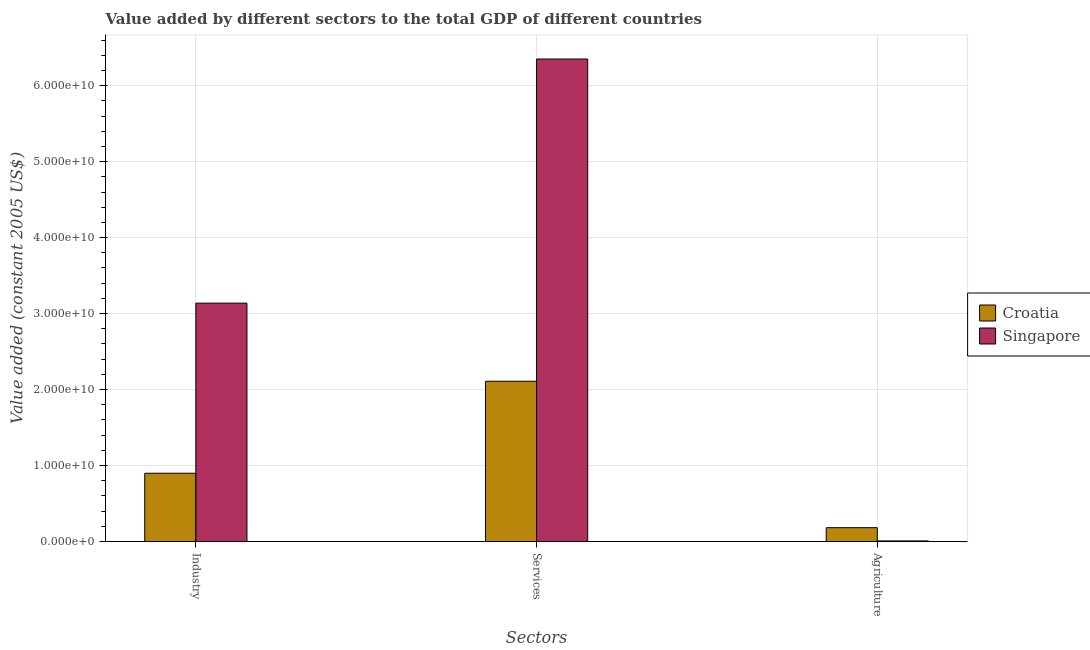Are the number of bars per tick equal to the number of legend labels?
Give a very brief answer. Yes. How many bars are there on the 3rd tick from the right?
Your answer should be very brief. 2. What is the label of the 3rd group of bars from the left?
Keep it short and to the point. Agriculture. What is the value added by industrial sector in Singapore?
Give a very brief answer. 3.14e+1. Across all countries, what is the maximum value added by agricultural sector?
Provide a succinct answer. 1.83e+09. Across all countries, what is the minimum value added by agricultural sector?
Give a very brief answer. 8.63e+07. In which country was the value added by industrial sector maximum?
Your answer should be compact. Singapore. In which country was the value added by services minimum?
Make the answer very short. Croatia. What is the total value added by industrial sector in the graph?
Keep it short and to the point. 4.04e+1. What is the difference between the value added by services in Croatia and that in Singapore?
Ensure brevity in your answer.  -4.24e+1. What is the difference between the value added by industrial sector in Croatia and the value added by services in Singapore?
Keep it short and to the point. -5.45e+1. What is the average value added by services per country?
Ensure brevity in your answer.  4.23e+1. What is the difference between the value added by services and value added by agricultural sector in Singapore?
Your answer should be very brief. 6.34e+1. What is the ratio of the value added by services in Singapore to that in Croatia?
Your answer should be very brief. 3.01. Is the value added by services in Singapore less than that in Croatia?
Your answer should be very brief. No. Is the difference between the value added by services in Croatia and Singapore greater than the difference between the value added by industrial sector in Croatia and Singapore?
Make the answer very short. No. What is the difference between the highest and the second highest value added by industrial sector?
Ensure brevity in your answer.  2.24e+1. What is the difference between the highest and the lowest value added by agricultural sector?
Give a very brief answer. 1.74e+09. In how many countries, is the value added by industrial sector greater than the average value added by industrial sector taken over all countries?
Ensure brevity in your answer.  1. Is the sum of the value added by services in Singapore and Croatia greater than the maximum value added by industrial sector across all countries?
Your response must be concise. Yes. What does the 2nd bar from the left in Agriculture represents?
Keep it short and to the point. Singapore. What does the 2nd bar from the right in Agriculture represents?
Provide a short and direct response. Croatia. Is it the case that in every country, the sum of the value added by industrial sector and value added by services is greater than the value added by agricultural sector?
Provide a short and direct response. Yes. How many countries are there in the graph?
Offer a terse response. 2. What is the difference between two consecutive major ticks on the Y-axis?
Your answer should be compact. 1.00e+1. Are the values on the major ticks of Y-axis written in scientific E-notation?
Your answer should be compact. Yes. Does the graph contain grids?
Provide a short and direct response. Yes. Where does the legend appear in the graph?
Provide a succinct answer. Center right. How are the legend labels stacked?
Your answer should be compact. Vertical. What is the title of the graph?
Offer a very short reply. Value added by different sectors to the total GDP of different countries. Does "Faeroe Islands" appear as one of the legend labels in the graph?
Your answer should be compact. No. What is the label or title of the X-axis?
Your answer should be very brief. Sectors. What is the label or title of the Y-axis?
Keep it short and to the point. Value added (constant 2005 US$). What is the Value added (constant 2005 US$) of Croatia in Industry?
Offer a very short reply. 8.99e+09. What is the Value added (constant 2005 US$) of Singapore in Industry?
Make the answer very short. 3.14e+1. What is the Value added (constant 2005 US$) of Croatia in Services?
Your answer should be compact. 2.11e+1. What is the Value added (constant 2005 US$) of Singapore in Services?
Give a very brief answer. 6.35e+1. What is the Value added (constant 2005 US$) of Croatia in Agriculture?
Give a very brief answer. 1.83e+09. What is the Value added (constant 2005 US$) in Singapore in Agriculture?
Your answer should be compact. 8.63e+07. Across all Sectors, what is the maximum Value added (constant 2005 US$) in Croatia?
Provide a short and direct response. 2.11e+1. Across all Sectors, what is the maximum Value added (constant 2005 US$) of Singapore?
Keep it short and to the point. 6.35e+1. Across all Sectors, what is the minimum Value added (constant 2005 US$) of Croatia?
Make the answer very short. 1.83e+09. Across all Sectors, what is the minimum Value added (constant 2005 US$) in Singapore?
Your answer should be compact. 8.63e+07. What is the total Value added (constant 2005 US$) in Croatia in the graph?
Your response must be concise. 3.19e+1. What is the total Value added (constant 2005 US$) in Singapore in the graph?
Offer a terse response. 9.50e+1. What is the difference between the Value added (constant 2005 US$) in Croatia in Industry and that in Services?
Ensure brevity in your answer.  -1.21e+1. What is the difference between the Value added (constant 2005 US$) of Singapore in Industry and that in Services?
Keep it short and to the point. -3.21e+1. What is the difference between the Value added (constant 2005 US$) in Croatia in Industry and that in Agriculture?
Your answer should be compact. 7.16e+09. What is the difference between the Value added (constant 2005 US$) of Singapore in Industry and that in Agriculture?
Offer a terse response. 3.13e+1. What is the difference between the Value added (constant 2005 US$) of Croatia in Services and that in Agriculture?
Ensure brevity in your answer.  1.93e+1. What is the difference between the Value added (constant 2005 US$) of Singapore in Services and that in Agriculture?
Your response must be concise. 6.34e+1. What is the difference between the Value added (constant 2005 US$) in Croatia in Industry and the Value added (constant 2005 US$) in Singapore in Services?
Ensure brevity in your answer.  -5.45e+1. What is the difference between the Value added (constant 2005 US$) of Croatia in Industry and the Value added (constant 2005 US$) of Singapore in Agriculture?
Provide a succinct answer. 8.90e+09. What is the difference between the Value added (constant 2005 US$) of Croatia in Services and the Value added (constant 2005 US$) of Singapore in Agriculture?
Make the answer very short. 2.10e+1. What is the average Value added (constant 2005 US$) in Croatia per Sectors?
Provide a succinct answer. 1.06e+1. What is the average Value added (constant 2005 US$) of Singapore per Sectors?
Give a very brief answer. 3.17e+1. What is the difference between the Value added (constant 2005 US$) in Croatia and Value added (constant 2005 US$) in Singapore in Industry?
Offer a very short reply. -2.24e+1. What is the difference between the Value added (constant 2005 US$) of Croatia and Value added (constant 2005 US$) of Singapore in Services?
Ensure brevity in your answer.  -4.24e+1. What is the difference between the Value added (constant 2005 US$) of Croatia and Value added (constant 2005 US$) of Singapore in Agriculture?
Ensure brevity in your answer.  1.74e+09. What is the ratio of the Value added (constant 2005 US$) of Croatia in Industry to that in Services?
Offer a very short reply. 0.43. What is the ratio of the Value added (constant 2005 US$) in Singapore in Industry to that in Services?
Your answer should be very brief. 0.49. What is the ratio of the Value added (constant 2005 US$) of Croatia in Industry to that in Agriculture?
Provide a short and direct response. 4.92. What is the ratio of the Value added (constant 2005 US$) of Singapore in Industry to that in Agriculture?
Keep it short and to the point. 363.66. What is the ratio of the Value added (constant 2005 US$) of Croatia in Services to that in Agriculture?
Offer a terse response. 11.54. What is the ratio of the Value added (constant 2005 US$) of Singapore in Services to that in Agriculture?
Keep it short and to the point. 736.07. What is the difference between the highest and the second highest Value added (constant 2005 US$) in Croatia?
Provide a short and direct response. 1.21e+1. What is the difference between the highest and the second highest Value added (constant 2005 US$) of Singapore?
Offer a very short reply. 3.21e+1. What is the difference between the highest and the lowest Value added (constant 2005 US$) of Croatia?
Provide a succinct answer. 1.93e+1. What is the difference between the highest and the lowest Value added (constant 2005 US$) in Singapore?
Give a very brief answer. 6.34e+1. 